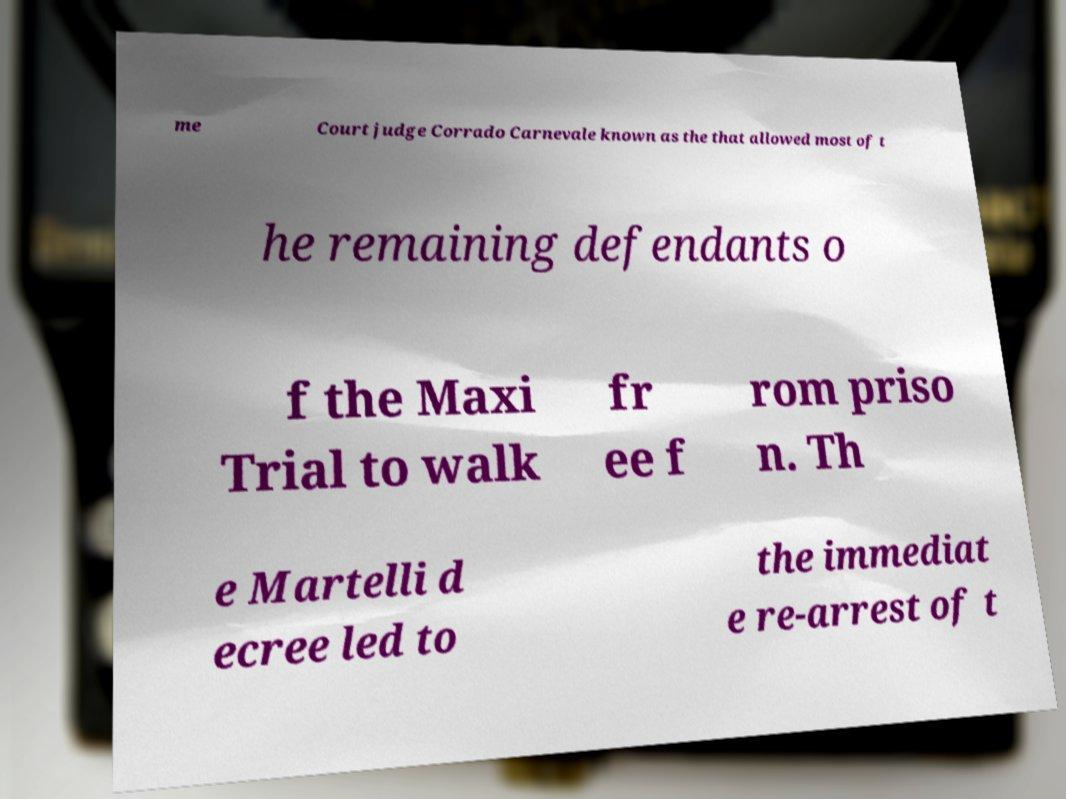Please identify and transcribe the text found in this image. me Court judge Corrado Carnevale known as the that allowed most of t he remaining defendants o f the Maxi Trial to walk fr ee f rom priso n. Th e Martelli d ecree led to the immediat e re-arrest of t 